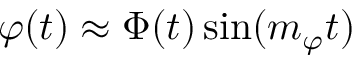<formula> <loc_0><loc_0><loc_500><loc_500>\varphi ( t ) \approx \Phi ( t ) \sin ( m _ { \varphi } t )</formula> 